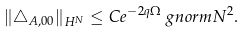<formula> <loc_0><loc_0><loc_500><loc_500>\| \triangle _ { A , 0 0 } \| _ { H ^ { N } } & \leq C e ^ { - 2 q \Omega } \ g n o r m { N } ^ { 2 } .</formula> 